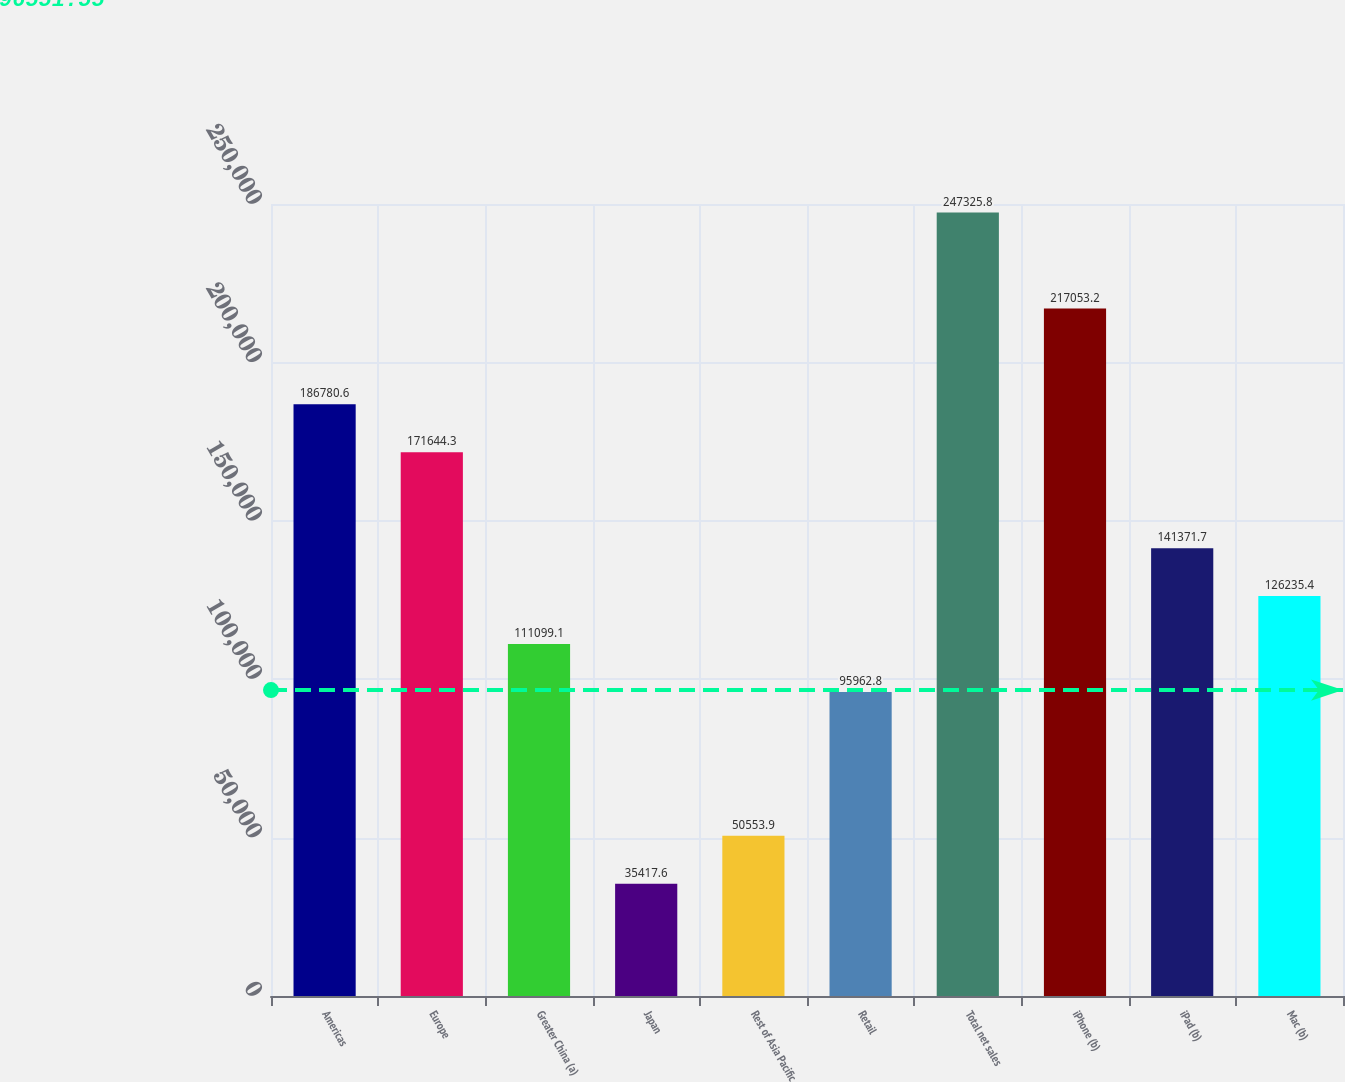Convert chart to OTSL. <chart><loc_0><loc_0><loc_500><loc_500><bar_chart><fcel>Americas<fcel>Europe<fcel>Greater China (a)<fcel>Japan<fcel>Rest of Asia Pacific<fcel>Retail<fcel>Total net sales<fcel>iPhone (b)<fcel>iPad (b)<fcel>Mac (b)<nl><fcel>186781<fcel>171644<fcel>111099<fcel>35417.6<fcel>50553.9<fcel>95962.8<fcel>247326<fcel>217053<fcel>141372<fcel>126235<nl></chart> 